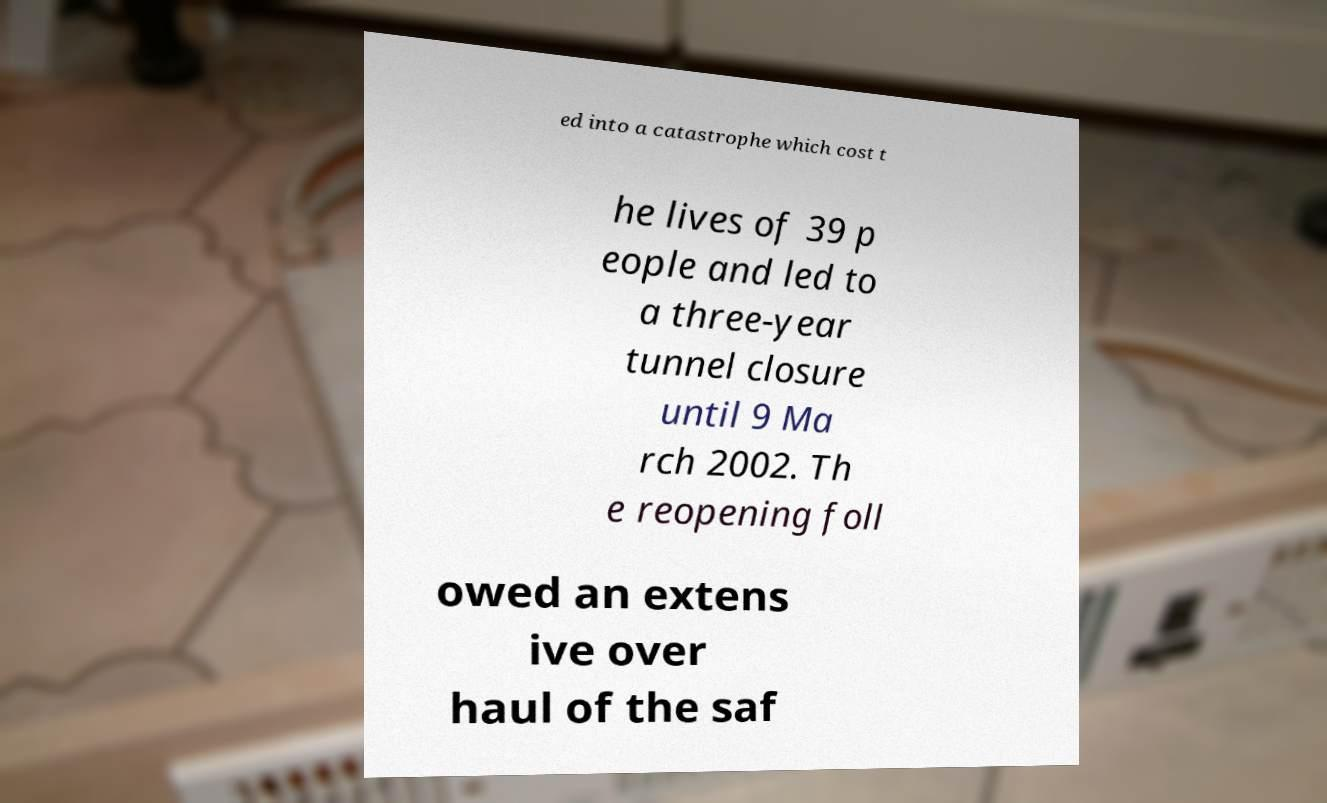For documentation purposes, I need the text within this image transcribed. Could you provide that? ed into a catastrophe which cost t he lives of 39 p eople and led to a three-year tunnel closure until 9 Ma rch 2002. Th e reopening foll owed an extens ive over haul of the saf 